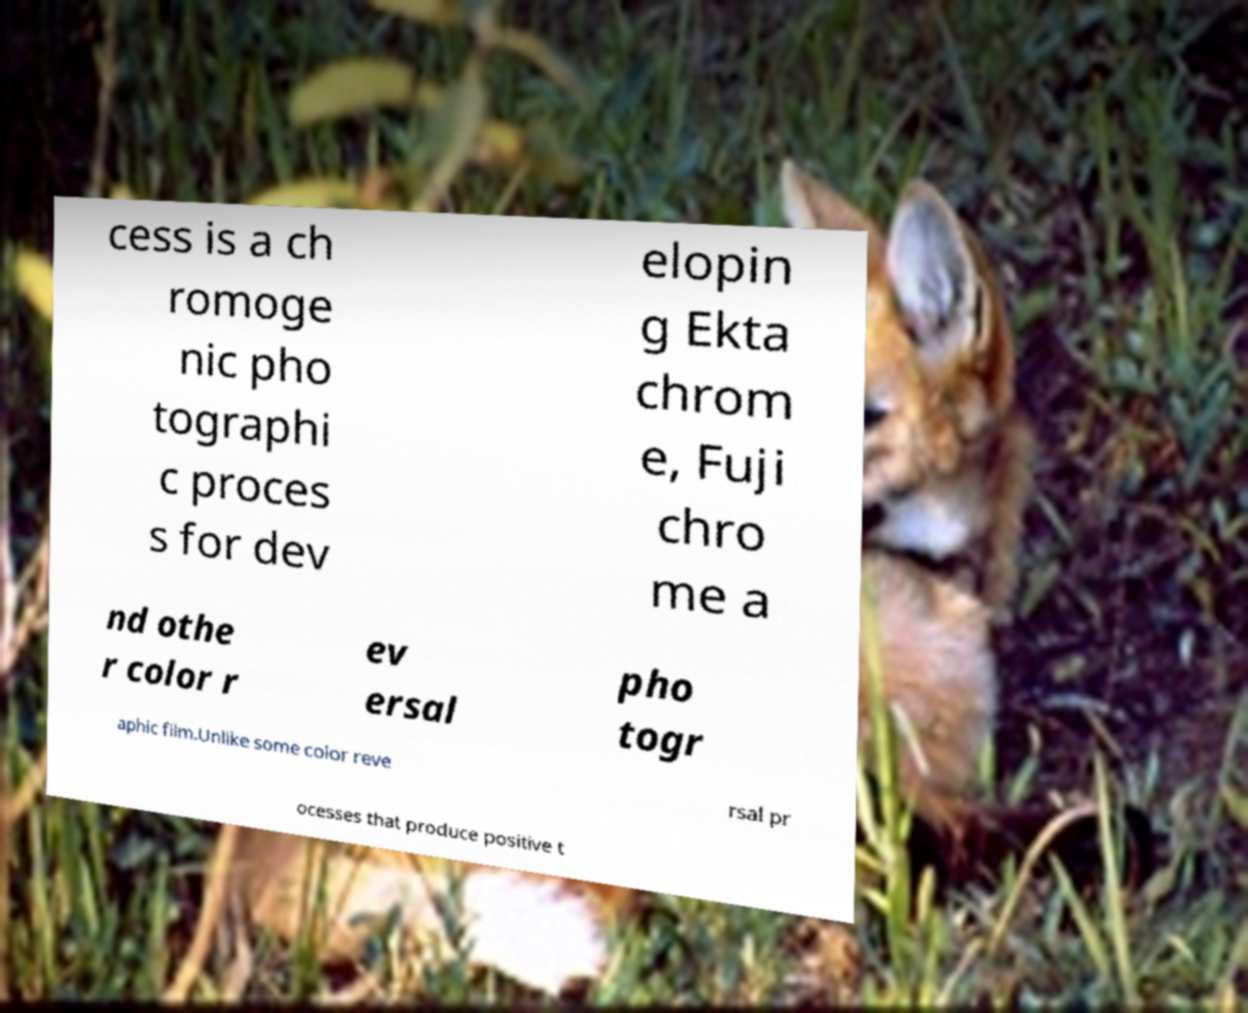Please identify and transcribe the text found in this image. cess is a ch romoge nic pho tographi c proces s for dev elopin g Ekta chrom e, Fuji chro me a nd othe r color r ev ersal pho togr aphic film.Unlike some color reve rsal pr ocesses that produce positive t 